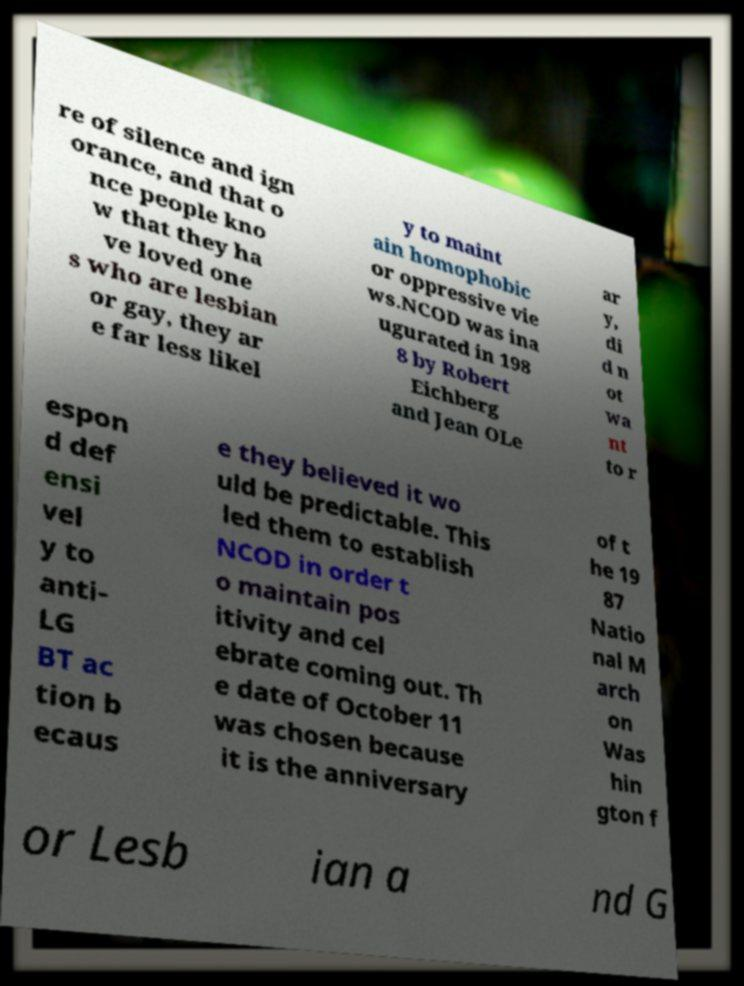Could you assist in decoding the text presented in this image and type it out clearly? re of silence and ign orance, and that o nce people kno w that they ha ve loved one s who are lesbian or gay, they ar e far less likel y to maint ain homophobic or oppressive vie ws.NCOD was ina ugurated in 198 8 by Robert Eichberg and Jean OLe ar y, di d n ot wa nt to r espon d def ensi vel y to anti- LG BT ac tion b ecaus e they believed it wo uld be predictable. This led them to establish NCOD in order t o maintain pos itivity and cel ebrate coming out. Th e date of October 11 was chosen because it is the anniversary of t he 19 87 Natio nal M arch on Was hin gton f or Lesb ian a nd G 